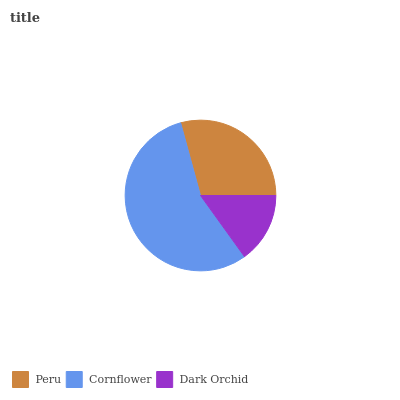Is Dark Orchid the minimum?
Answer yes or no. Yes. Is Cornflower the maximum?
Answer yes or no. Yes. Is Cornflower the minimum?
Answer yes or no. No. Is Dark Orchid the maximum?
Answer yes or no. No. Is Cornflower greater than Dark Orchid?
Answer yes or no. Yes. Is Dark Orchid less than Cornflower?
Answer yes or no. Yes. Is Dark Orchid greater than Cornflower?
Answer yes or no. No. Is Cornflower less than Dark Orchid?
Answer yes or no. No. Is Peru the high median?
Answer yes or no. Yes. Is Peru the low median?
Answer yes or no. Yes. Is Cornflower the high median?
Answer yes or no. No. Is Dark Orchid the low median?
Answer yes or no. No. 